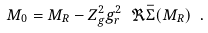<formula> <loc_0><loc_0><loc_500><loc_500>M _ { 0 } = M _ { R } - Z _ { g } ^ { 2 } g _ { r } ^ { 2 } \ \Re \bar { \Sigma } ( M _ { R } ) \ .</formula> 